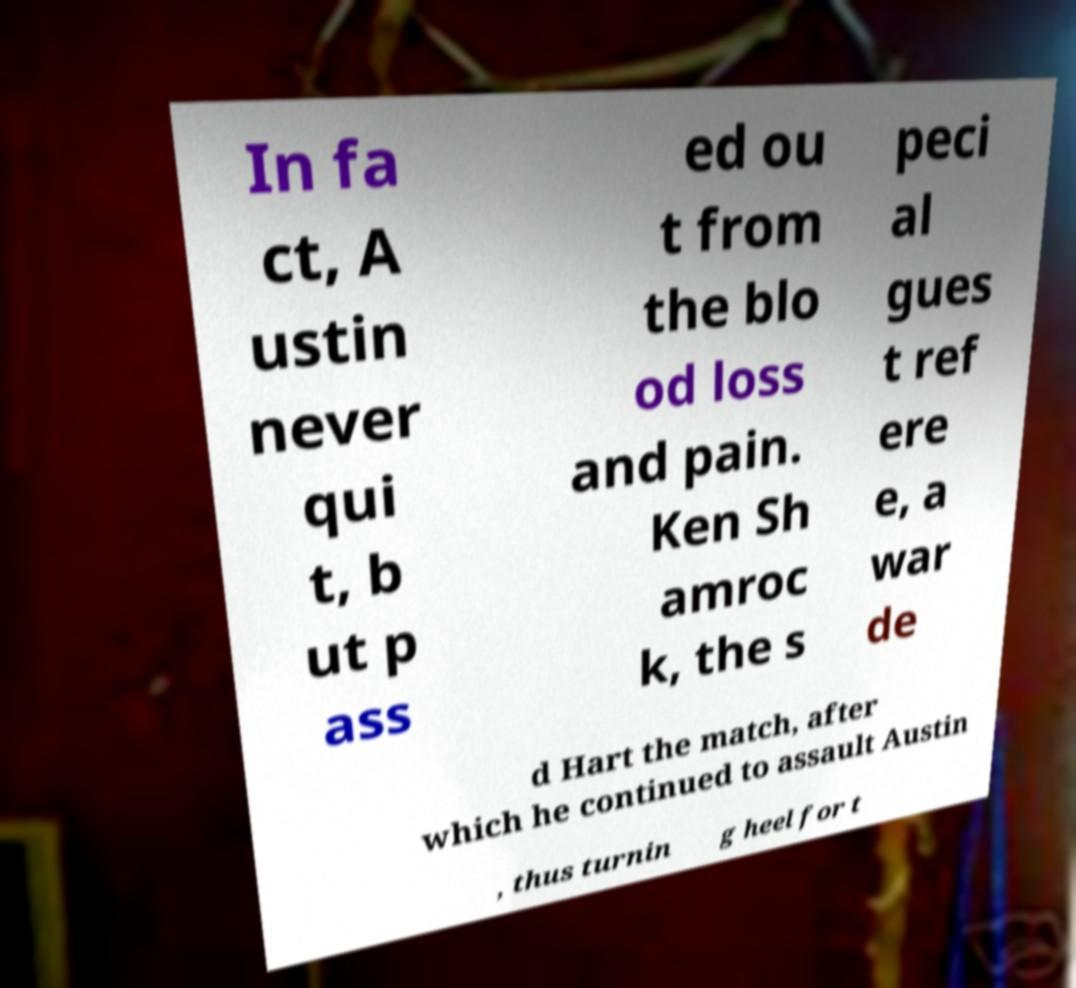Could you extract and type out the text from this image? In fa ct, A ustin never qui t, b ut p ass ed ou t from the blo od loss and pain. Ken Sh amroc k, the s peci al gues t ref ere e, a war de d Hart the match, after which he continued to assault Austin , thus turnin g heel for t 